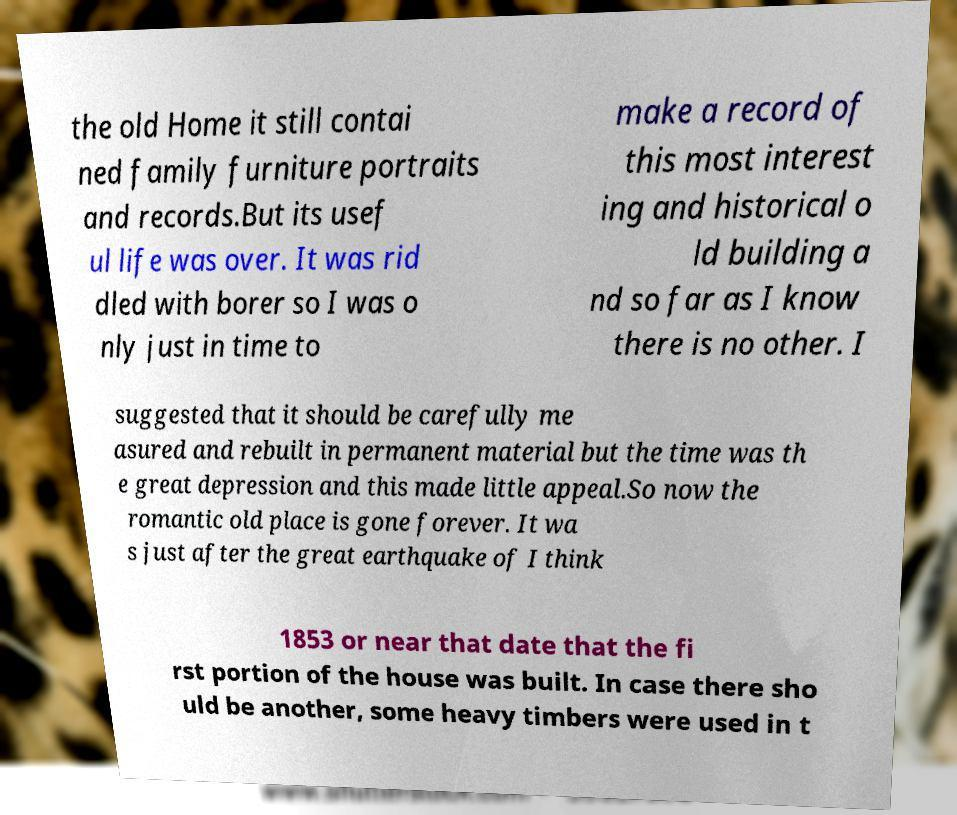Please identify and transcribe the text found in this image. the old Home it still contai ned family furniture portraits and records.But its usef ul life was over. It was rid dled with borer so I was o nly just in time to make a record of this most interest ing and historical o ld building a nd so far as I know there is no other. I suggested that it should be carefully me asured and rebuilt in permanent material but the time was th e great depression and this made little appeal.So now the romantic old place is gone forever. It wa s just after the great earthquake of I think 1853 or near that date that the fi rst portion of the house was built. In case there sho uld be another, some heavy timbers were used in t 